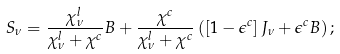Convert formula to latex. <formula><loc_0><loc_0><loc_500><loc_500>S _ { \nu } = \frac { \chi _ { \nu } ^ { l } } { \chi _ { \nu } ^ { l } + \chi ^ { c } } B + \frac { \chi ^ { c } } { \chi _ { \nu } ^ { l } + \chi ^ { c } } \left ( \left [ 1 - \epsilon ^ { c } \right ] J _ { \nu } + \epsilon ^ { c } B \right ) ;</formula> 